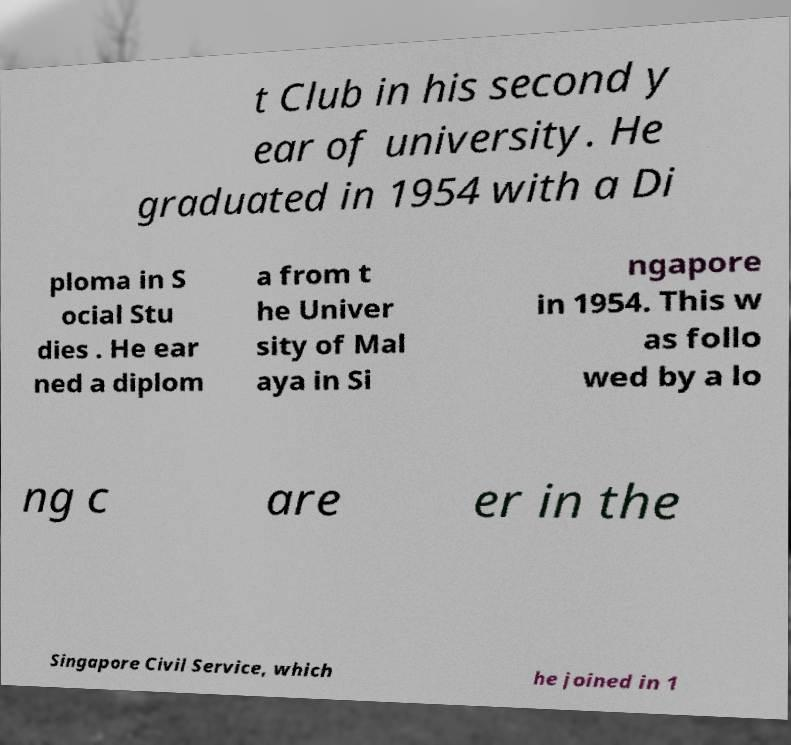Could you extract and type out the text from this image? t Club in his second y ear of university. He graduated in 1954 with a Di ploma in S ocial Stu dies . He ear ned a diplom a from t he Univer sity of Mal aya in Si ngapore in 1954. This w as follo wed by a lo ng c are er in the Singapore Civil Service, which he joined in 1 